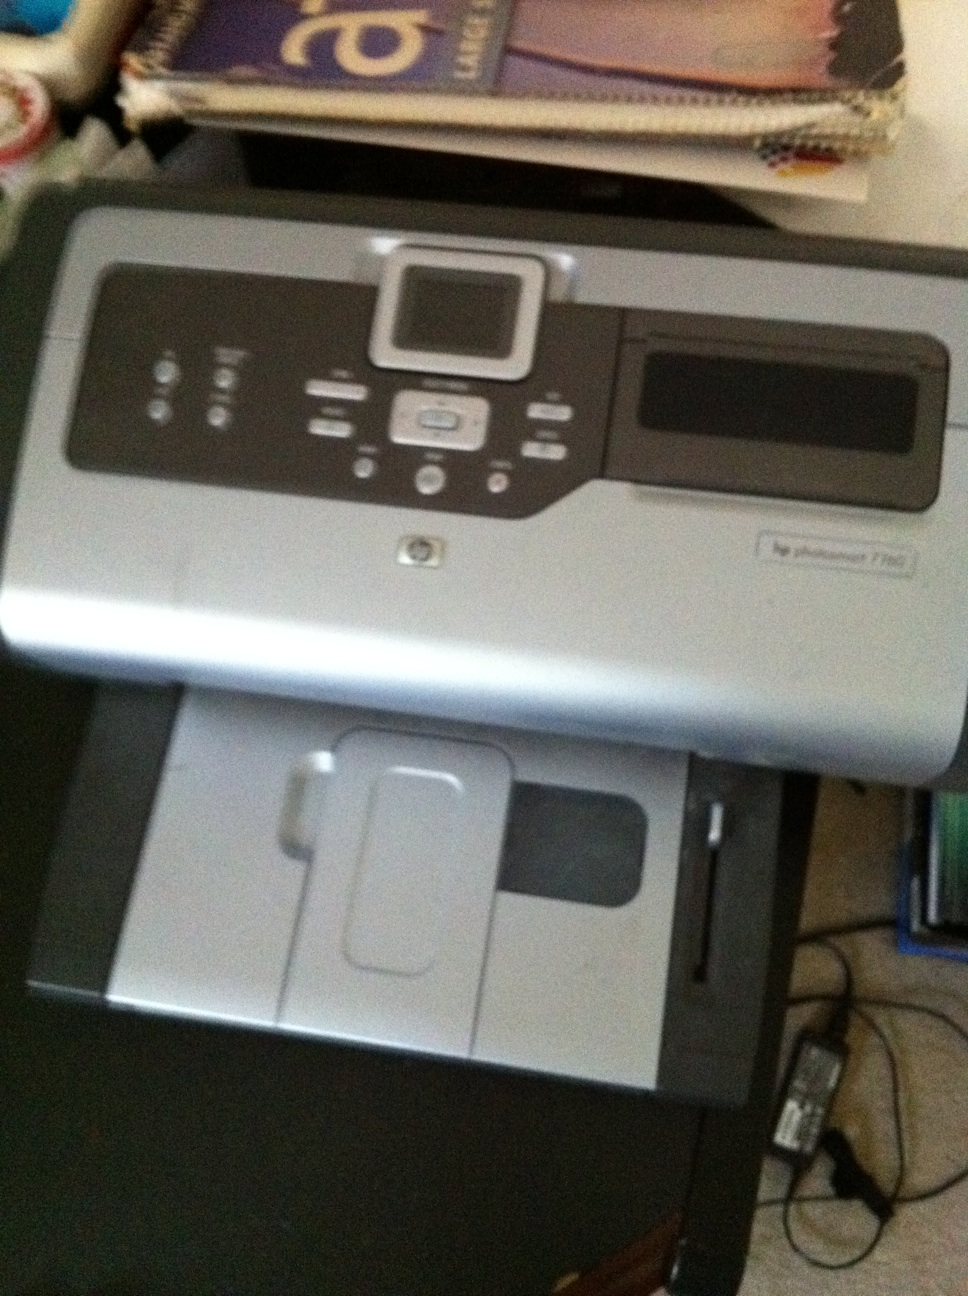What's the most creative project someone can use this printer for? One of the most creative projects you can use the HP Photosmart 7280 for is designing and printing custom photo albums or scrapbooks. With its high-quality photo printing capabilities, you can create personalized photo collections, greeting cards, calendars, and even art prints. Another creative idea is using it for printing stickers or decals if you pair it with adhesive paper. It can be a wonderful tool for artists and crafters to explore their creativity. 